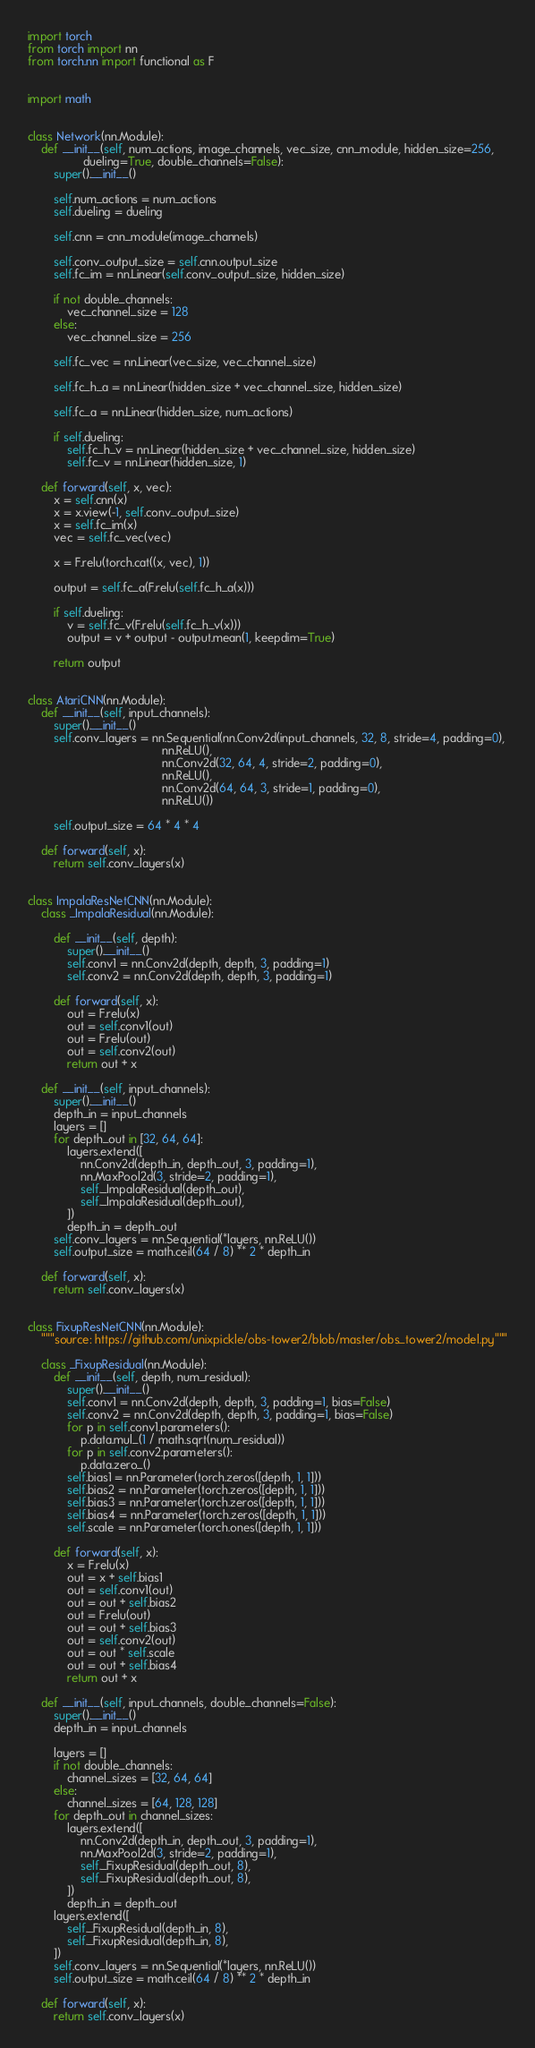<code> <loc_0><loc_0><loc_500><loc_500><_Python_>import torch
from torch import nn
from torch.nn import functional as F


import math


class Network(nn.Module):
    def __init__(self, num_actions, image_channels, vec_size, cnn_module, hidden_size=256,
                 dueling=True, double_channels=False):
        super().__init__()

        self.num_actions = num_actions
        self.dueling = dueling

        self.cnn = cnn_module(image_channels)

        self.conv_output_size = self.cnn.output_size
        self.fc_im = nn.Linear(self.conv_output_size, hidden_size)

        if not double_channels:
            vec_channel_size = 128
        else:
            vec_channel_size = 256

        self.fc_vec = nn.Linear(vec_size, vec_channel_size)

        self.fc_h_a = nn.Linear(hidden_size + vec_channel_size, hidden_size)
        
        self.fc_a = nn.Linear(hidden_size, num_actions)

        if self.dueling:
            self.fc_h_v = nn.Linear(hidden_size + vec_channel_size, hidden_size)
            self.fc_v = nn.Linear(hidden_size, 1)

    def forward(self, x, vec):
        x = self.cnn(x)
        x = x.view(-1, self.conv_output_size)
        x = self.fc_im(x)
        vec = self.fc_vec(vec)

        x = F.relu(torch.cat((x, vec), 1))

        output = self.fc_a(F.relu(self.fc_h_a(x)))
        
        if self.dueling:
            v = self.fc_v(F.relu(self.fc_h_v(x)))
            output = v + output - output.mean(1, keepdim=True)

        return output


class AtariCNN(nn.Module):
    def __init__(self, input_channels):
        super().__init__()
        self.conv_layers = nn.Sequential(nn.Conv2d(input_channels, 32, 8, stride=4, padding=0),
                                         nn.ReLU(),
                                         nn.Conv2d(32, 64, 4, stride=2, padding=0),
                                         nn.ReLU(),
                                         nn.Conv2d(64, 64, 3, stride=1, padding=0),
                                         nn.ReLU())

        self.output_size = 64 * 4 * 4

    def forward(self, x):
        return self.conv_layers(x)


class ImpalaResNetCNN(nn.Module):
    class _ImpalaResidual(nn.Module):

        def __init__(self, depth):
            super().__init__()
            self.conv1 = nn.Conv2d(depth, depth, 3, padding=1)
            self.conv2 = nn.Conv2d(depth, depth, 3, padding=1)

        def forward(self, x):
            out = F.relu(x)
            out = self.conv1(out)
            out = F.relu(out)
            out = self.conv2(out)
            return out + x

    def __init__(self, input_channels):
        super().__init__()
        depth_in = input_channels
        layers = []
        for depth_out in [32, 64, 64]:
            layers.extend([
                nn.Conv2d(depth_in, depth_out, 3, padding=1),
                nn.MaxPool2d(3, stride=2, padding=1),
                self._ImpalaResidual(depth_out),
                self._ImpalaResidual(depth_out),
            ])
            depth_in = depth_out
        self.conv_layers = nn.Sequential(*layers, nn.ReLU())
        self.output_size = math.ceil(64 / 8) ** 2 * depth_in

    def forward(self, x):
        return self.conv_layers(x)


class FixupResNetCNN(nn.Module):
    """source: https://github.com/unixpickle/obs-tower2/blob/master/obs_tower2/model.py"""

    class _FixupResidual(nn.Module):
        def __init__(self, depth, num_residual):
            super().__init__()
            self.conv1 = nn.Conv2d(depth, depth, 3, padding=1, bias=False)
            self.conv2 = nn.Conv2d(depth, depth, 3, padding=1, bias=False)
            for p in self.conv1.parameters():
                p.data.mul_(1 / math.sqrt(num_residual))
            for p in self.conv2.parameters():
                p.data.zero_()
            self.bias1 = nn.Parameter(torch.zeros([depth, 1, 1]))
            self.bias2 = nn.Parameter(torch.zeros([depth, 1, 1]))
            self.bias3 = nn.Parameter(torch.zeros([depth, 1, 1]))
            self.bias4 = nn.Parameter(torch.zeros([depth, 1, 1]))
            self.scale = nn.Parameter(torch.ones([depth, 1, 1]))

        def forward(self, x):
            x = F.relu(x)
            out = x + self.bias1
            out = self.conv1(out)
            out = out + self.bias2
            out = F.relu(out)
            out = out + self.bias3
            out = self.conv2(out)
            out = out * self.scale
            out = out + self.bias4
            return out + x

    def __init__(self, input_channels, double_channels=False):
        super().__init__()
        depth_in = input_channels

        layers = []
        if not double_channels:
            channel_sizes = [32, 64, 64]
        else:
            channel_sizes = [64, 128, 128]
        for depth_out in channel_sizes:
            layers.extend([
                nn.Conv2d(depth_in, depth_out, 3, padding=1),
                nn.MaxPool2d(3, stride=2, padding=1),
                self._FixupResidual(depth_out, 8),
                self._FixupResidual(depth_out, 8),
            ])
            depth_in = depth_out
        layers.extend([
            self._FixupResidual(depth_in, 8),
            self._FixupResidual(depth_in, 8),
        ])
        self.conv_layers = nn.Sequential(*layers, nn.ReLU())
        self.output_size = math.ceil(64 / 8) ** 2 * depth_in

    def forward(self, x):
        return self.conv_layers(x)
</code> 